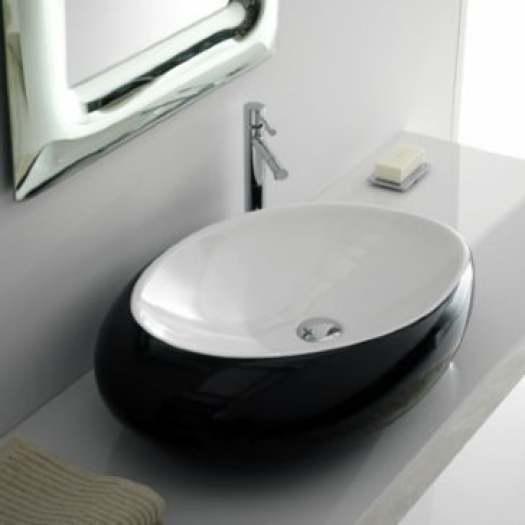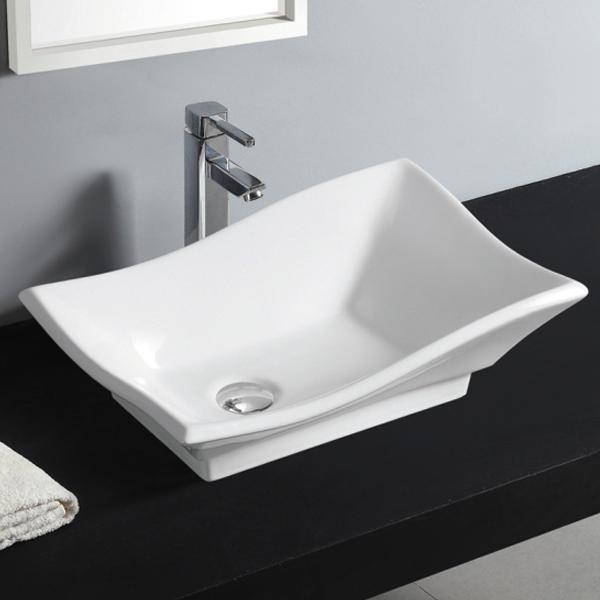The first image is the image on the left, the second image is the image on the right. Examine the images to the left and right. Is the description "The left image shows one rectangular sink which is inset and has a wide counter, and the right image shows a sink that is more square and does not have a wide counter." accurate? Answer yes or no. No. The first image is the image on the left, the second image is the image on the right. Given the left and right images, does the statement "Each sink is rectangular" hold true? Answer yes or no. No. 